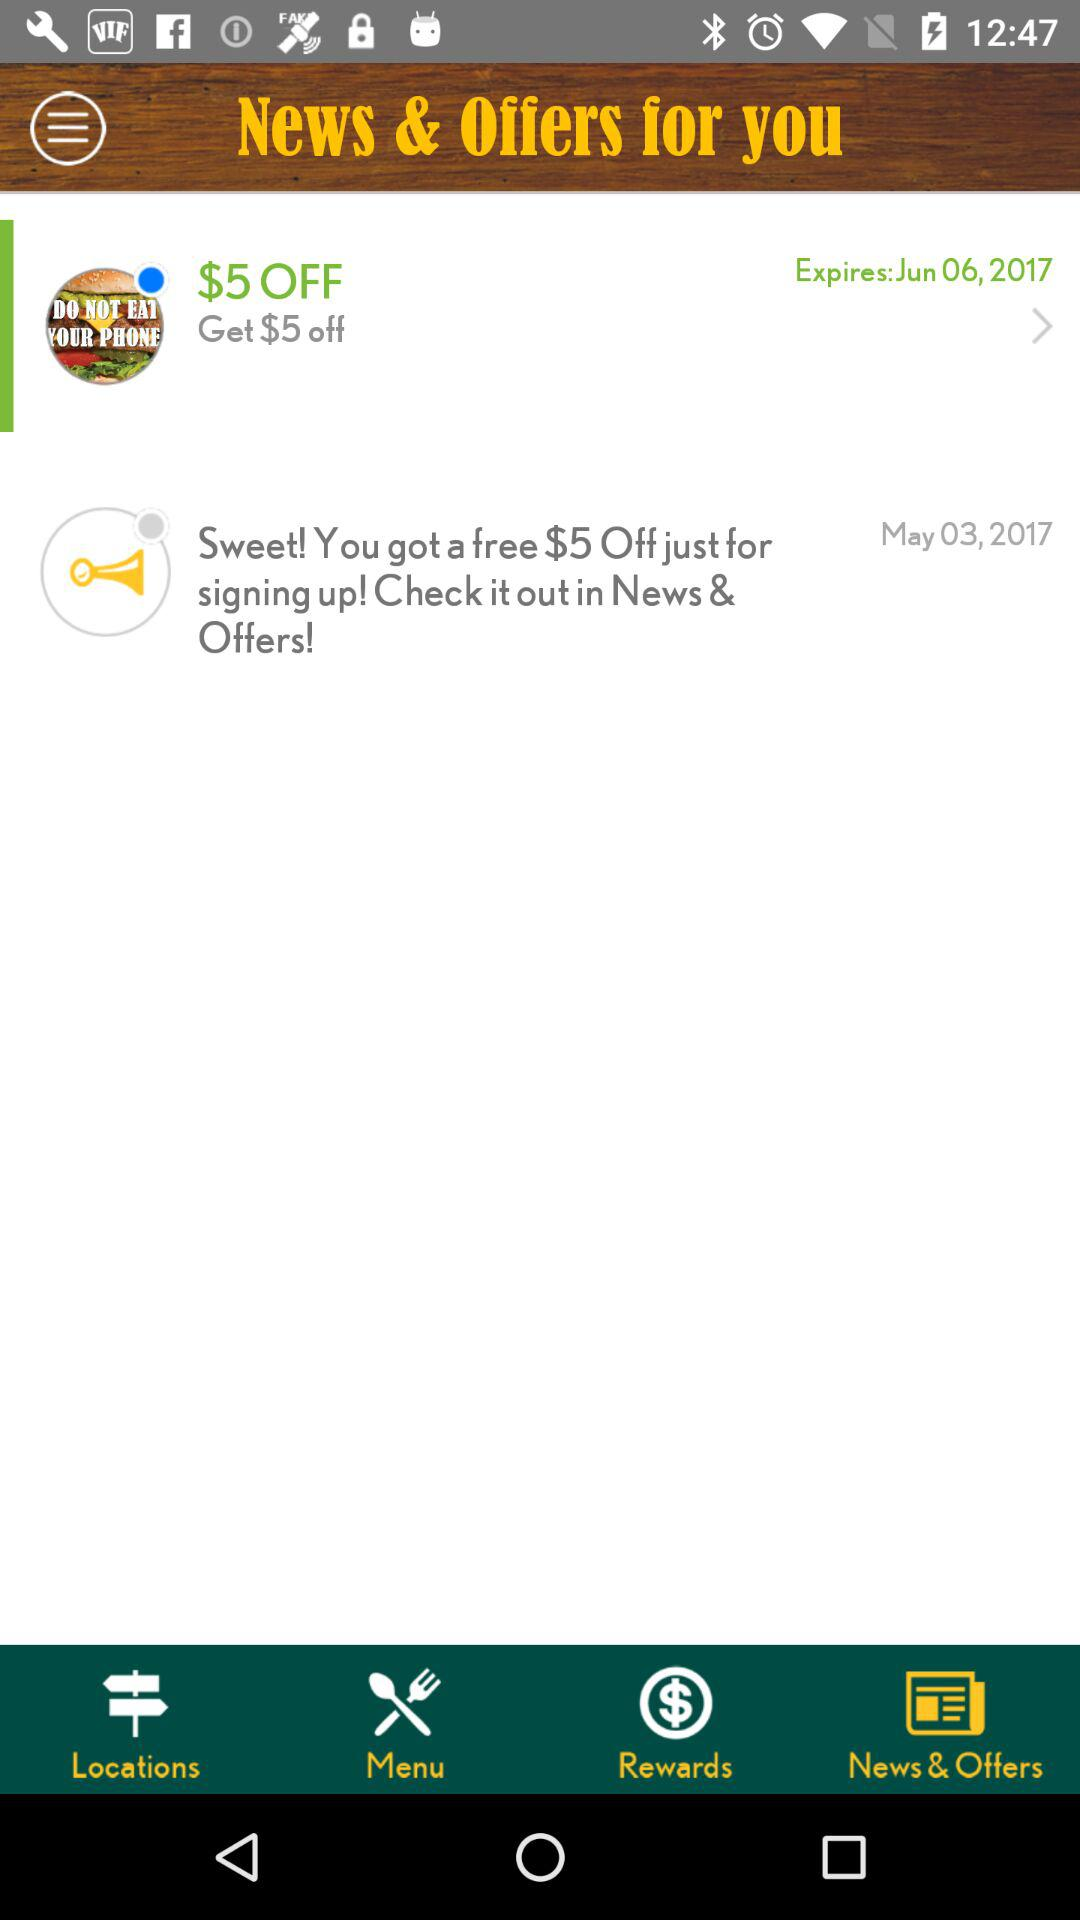What is the name of the application?
When the provided information is insufficient, respond with <no answer>. <no answer> 